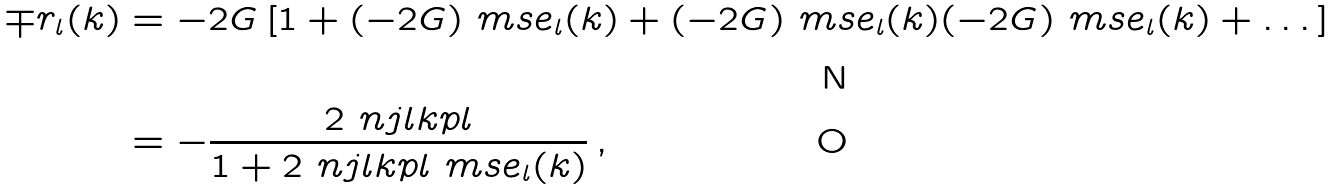Convert formula to latex. <formula><loc_0><loc_0><loc_500><loc_500>\mp r _ { l } ( k ) & = - 2 G \left [ 1 + ( - 2 G ) \ m s e _ { l } ( k ) + ( - 2 G ) \ m s e _ { l } ( k ) ( - 2 G ) \ m s e _ { l } ( k ) + \dots \right ] \\ & = - \frac { 2 \ n j l k p l } { 1 + 2 \ n j l k p l \ m s e _ { l } ( k ) } \, ,</formula> 